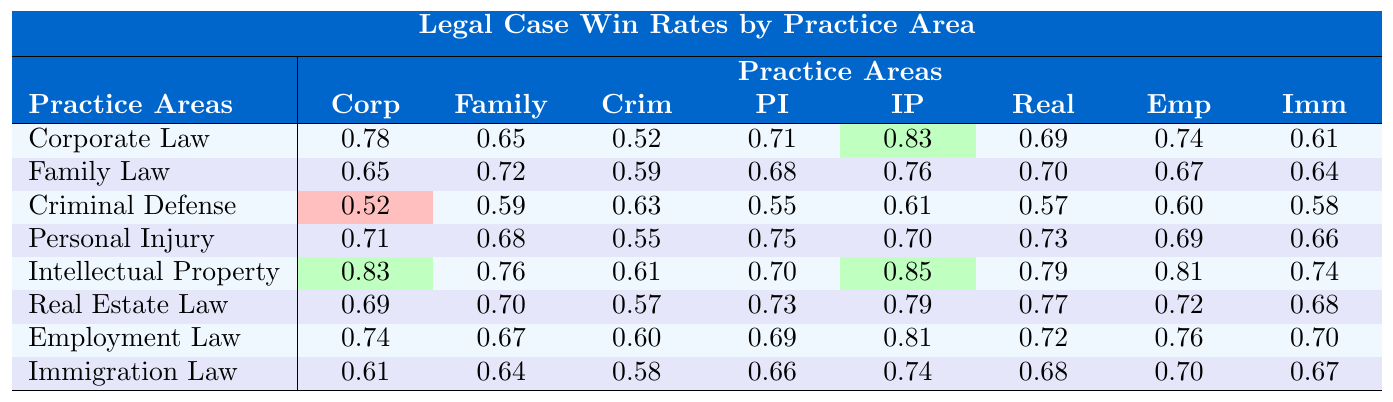What is the win rate for Corporate Law against Personal Injury? The table shows the win rates for various practice areas. For Corporate Law against Personal Injury, the win rate is 0.71.
Answer: 0.71 What is the highest win rate in the table? The highest win rate shown in the table is 0.85 under Intellectual Property.
Answer: 0.85 Does Criminal Defense have a win rate greater than 0.6 against any practice area? By checking the values, Criminal Defense has win rates of 0.61 against Intellectual Property, thus yes, it does have a win rate over 0.6 against one practice area.
Answer: Yes What is the average win rate of Employment Law across all practice areas? Sum the win rates: 0.74 + 0.67 + 0.60 + 0.69 + 0.81 + 0.72 + 0.76 + 0.70 = 5.99. There are 8 practice areas, so the average is 5.99 / 8 = 0.74875, which rounds to 0.75.
Answer: 0.75 Which practice area has the lowest win rate against Immigration Law? Check the win rates of all practice areas against Immigration Law. Criminal Defense has the lowest win rate of 0.58 against Immigration Law.
Answer: Criminal Defense What is the difference in the win rate between Intellectual Property and Real Estate Law? The win rate for Intellectual Property is 0.85 and for Real Estate Law, it's 0.79. Calculating the difference: 0.85 - 0.79 = 0.06.
Answer: 0.06 Which practice area wins against Criminal Defense the most? Observing the win rates under Criminal Defense, the highest win rate is 0.63 against Family Law.
Answer: Family Law What is the trend of win rates from Corporate Law to Immigration Law? Reviewing the first row to the last, there is no consistent trend as the values fluctuate; Corporate Law starts at 0.78 and Immigration Law ends at 0.67, indicating a decline.
Answer: No consistent trend 